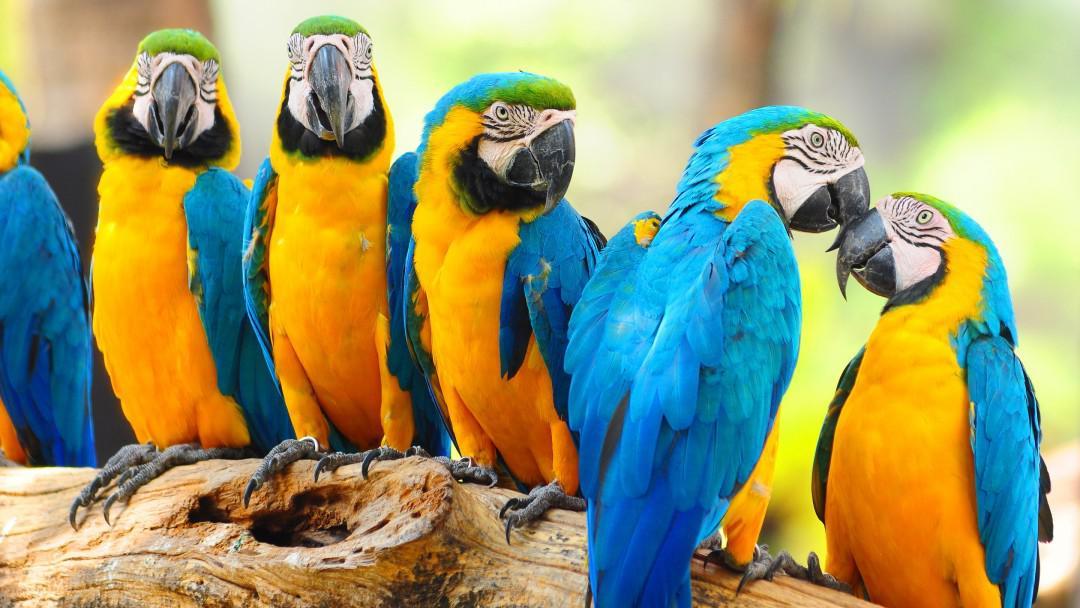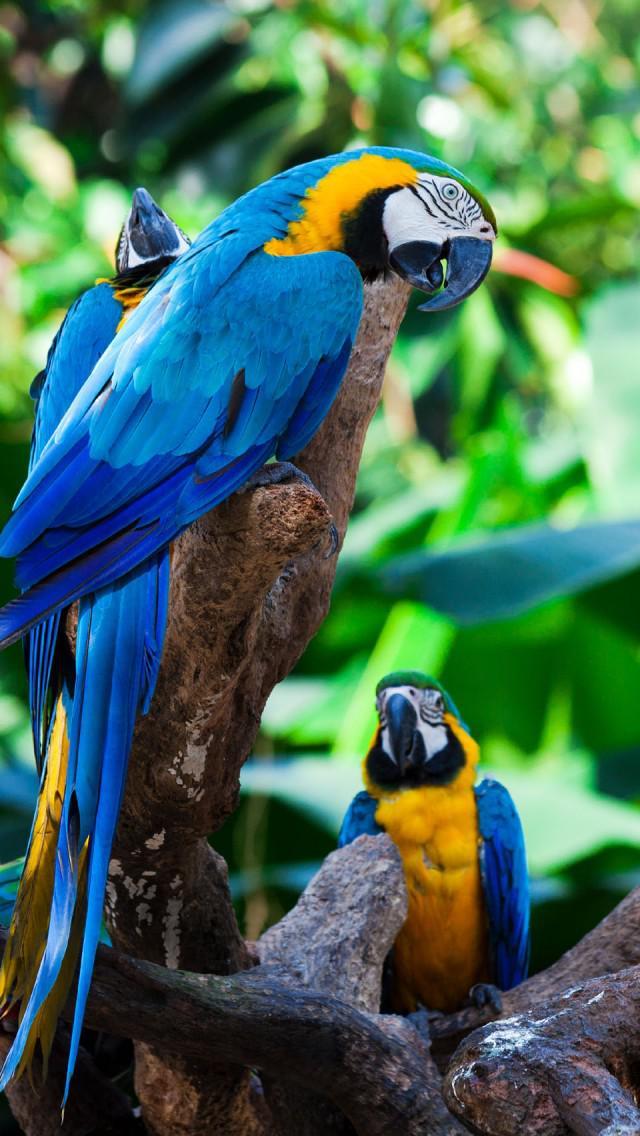The first image is the image on the left, the second image is the image on the right. Given the left and right images, does the statement "The parrot in the right image closest to the right side is blue and yellow." hold true? Answer yes or no. Yes. The first image is the image on the left, the second image is the image on the right. Assess this claim about the two images: "There are six colorful birds perched on a piece of wood in the image on the left.". Correct or not? Answer yes or no. Yes. 